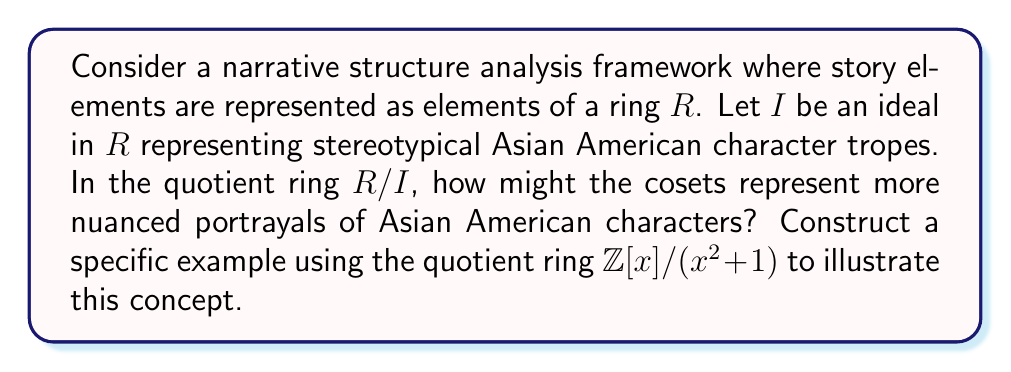Could you help me with this problem? To approach this question, let's break it down into steps:

1) First, we need to understand what the quotient ring $R/I$ represents in our narrative structure analysis:
   - Elements of $R$ are story elements
   - The ideal $I$ represents stereotypical tropes
   - Cosets in $R/I$ represent equivalence classes of story elements

2) In $R/I$, story elements that differ by stereotypical tropes are considered equivalent. This allows for more nuanced representations by focusing on the unique aspects of characters beyond stereotypes.

3) Now, let's consider the specific example of $\mathbb{Z}[x]/(x^2+1)$:
   - $\mathbb{Z}[x]$ is the ring of polynomials with integer coefficients
   - $(x^2+1)$ is the ideal generated by $x^2+1$

4) In this quotient ring:
   $$\mathbb{Z}[x]/(x^2+1) = \{a + bx + (x^2+1) : a, b \in \mathbb{Z}\}$$

5) We can interpret this as follows:
   - $x$ could represent a complex character trait
   - $x^2 = -1$ in this ring, suggesting that applying this trait twice reverts to a baseline (represented by -1)
   - Each coset $a + bx + (x^2+1)$ represents a character with a unique combination of baseline (a) and complex (bx) traits

6) For example:
   - $0 + 0x + (x^2+1)$ could represent a baseline character without stereotypes
   - $1 + 2x + (x^2+1)$ could represent a character with some baseline traits (1) and a stronger presence of complex traits (2x)
   - $-3 + x + (x^2+1)$ could represent a character that subverts baseline expectations (-3) with a moderate presence of complex traits (x)

This structure allows for a rich variety of character representations that go beyond simple stereotypes, aligning with the goal of exploring more nuanced portrayals of Asian American characters in contemporary media.
Answer: The cosets in $R/I$ represent equivalence classes of story elements that differ by stereotypical tropes, allowing for more nuanced character portrayals. In the specific example of $\mathbb{Z}[x]/(x^2+1)$, each coset $a + bx + (x^2+1)$ represents a unique character portrayal with $a$ representing baseline traits and $bx$ representing complex traits, providing a framework for diverse and non-stereotypical Asian American character representations. 